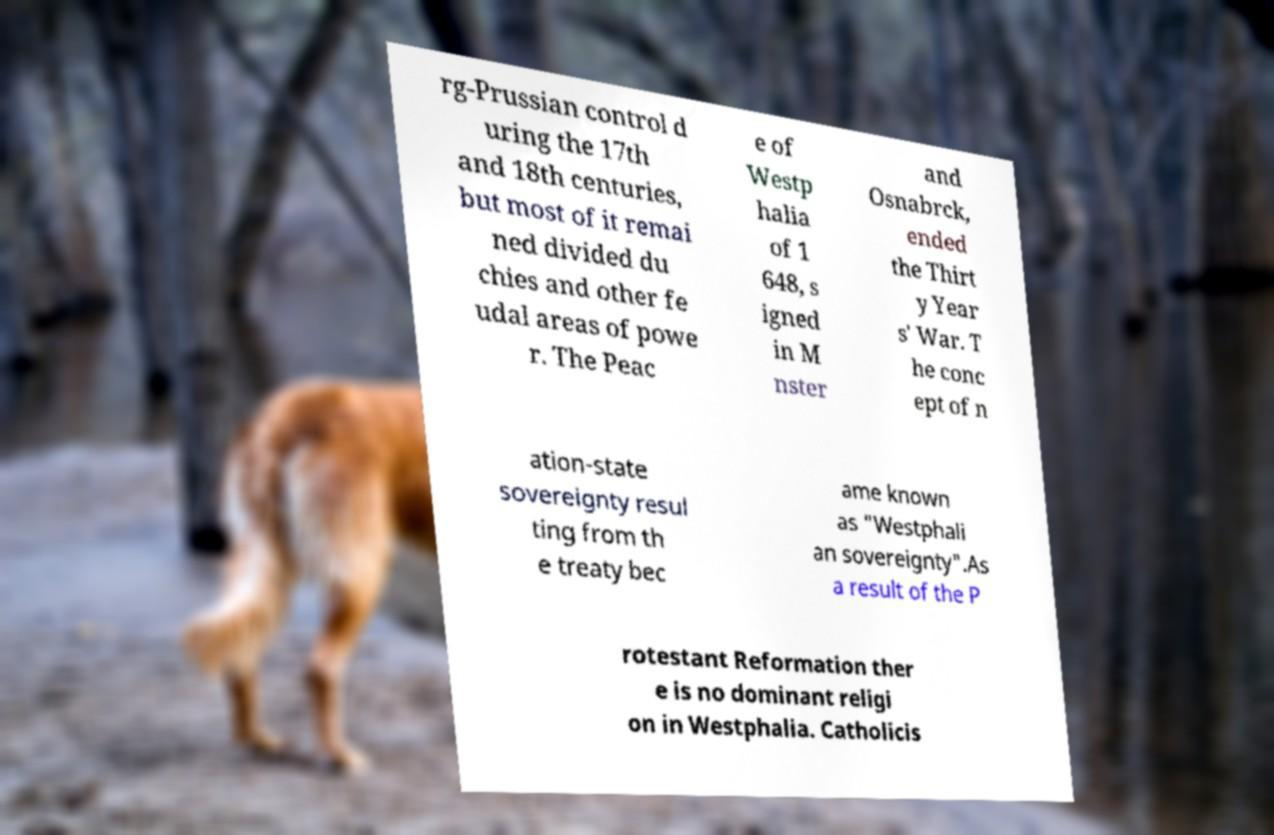I need the written content from this picture converted into text. Can you do that? rg-Prussian control d uring the 17th and 18th centuries, but most of it remai ned divided du chies and other fe udal areas of powe r. The Peac e of Westp halia of 1 648, s igned in M nster and Osnabrck, ended the Thirt y Year s' War. T he conc ept of n ation-state sovereignty resul ting from th e treaty bec ame known as "Westphali an sovereignty".As a result of the P rotestant Reformation ther e is no dominant religi on in Westphalia. Catholicis 